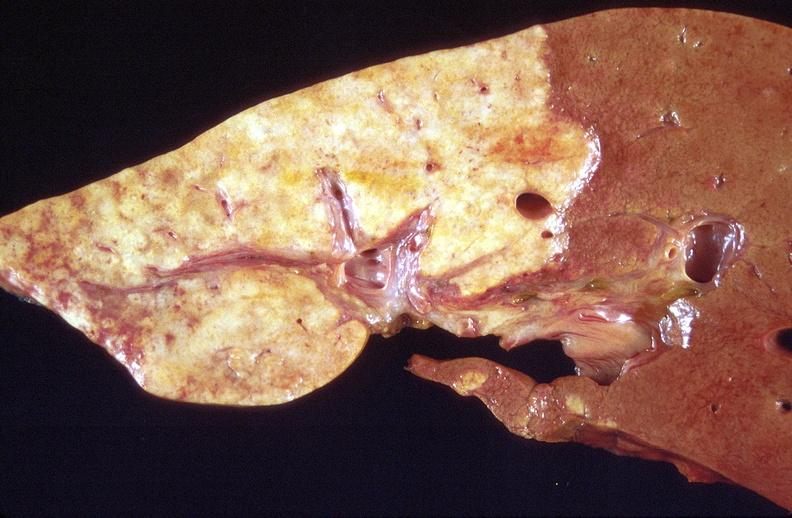s liver present?
Answer the question using a single word or phrase. Yes 